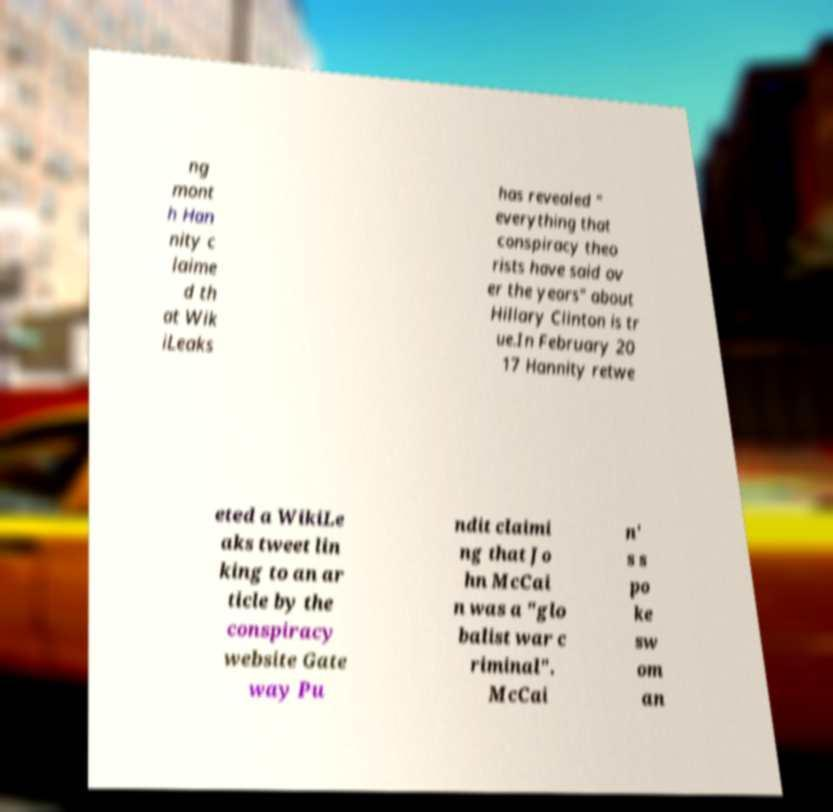Please read and relay the text visible in this image. What does it say? ng mont h Han nity c laime d th at Wik iLeaks has revealed " everything that conspiracy theo rists have said ov er the years" about Hillary Clinton is tr ue.In February 20 17 Hannity retwe eted a WikiLe aks tweet lin king to an ar ticle by the conspiracy website Gate way Pu ndit claimi ng that Jo hn McCai n was a "glo balist war c riminal". McCai n' s s po ke sw om an 